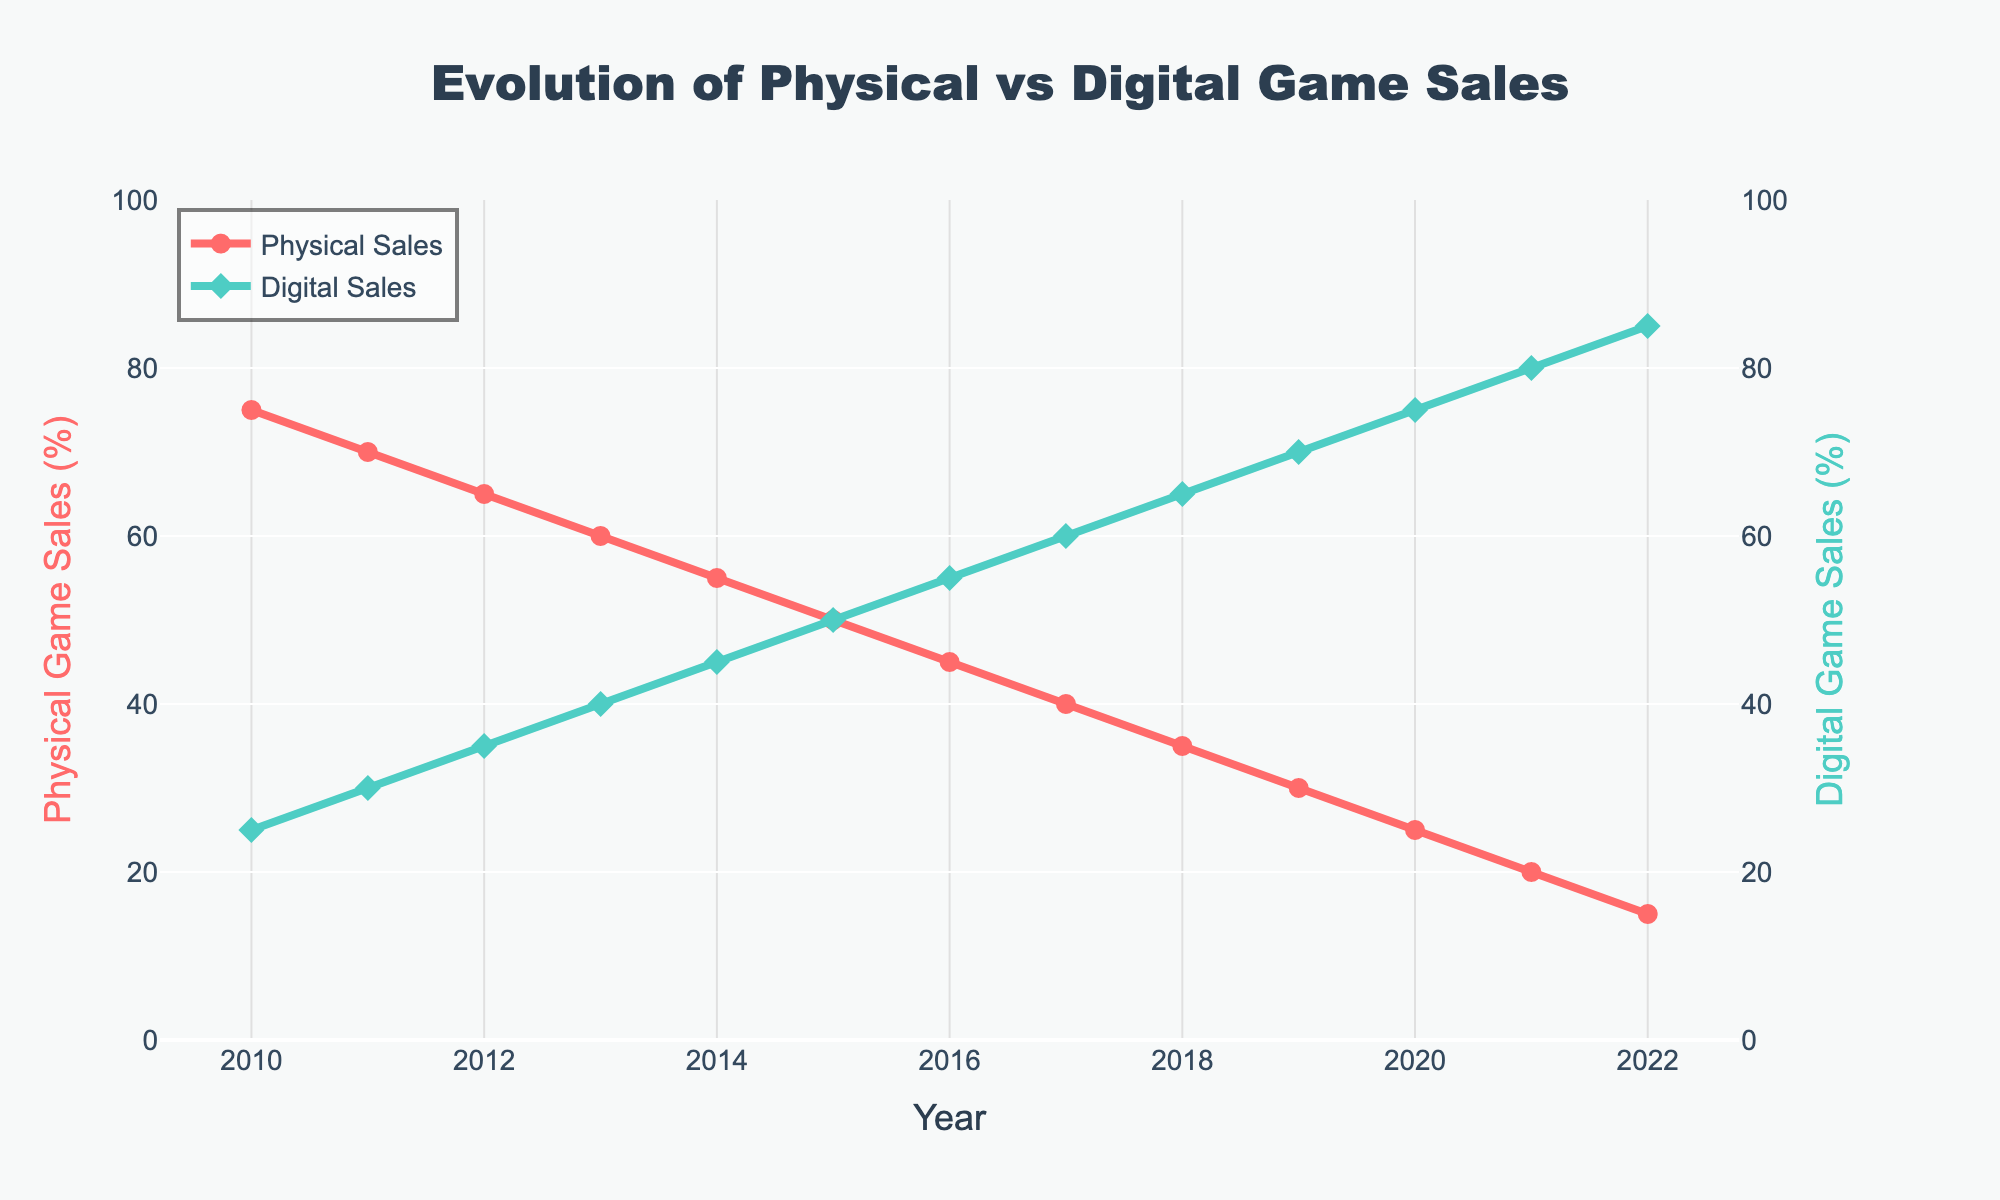What's the ratio of digital game sales to physical game sales in 2020? In 2020, digital game sales are 75% and physical game sales are 25%. So, the ratio is 75/25 = 3.
Answer: 3 How much did the percentage of digital game sales increase from 2010 to 2022? Digital game sales were 25% in 2010 and 85% in 2022. The increase is 85% - 25% = 60%.
Answer: 60% Which year marks the point when digital game sales exceeded physical game sales? The year when digital sales first exceeded physical sales is the year when digital sales percentage is higher than physical sales percentage. This happens in 2015 (50% digital and 50% physical).
Answer: 2015 What's the average percentage of physical game sales from 2010 to 2022? The percentages are: 75, 70, 65, 60, 55, 50, 45, 40, 35, 30, 25, 20, and 15. Sum them up: 75+70+65+60+55+50+45+40+35+30+25+20+15 = 585. There are 13 values, so the average is 585/13 ≈ 45%.
Answer: 45% By how much did physical game sales decrease between 2014 and 2021? Physical game sales were 55% in 2014 and 20% in 2021. The decrease is 55% - 20% = 35%.
Answer: 35% In which year is the difference between physical game sales and digital game sales the smallest? The smallest difference occurs when the absolute value of the difference between physical and digital percentages is smallest. This happens in 2015, where both are 50%.
Answer: 2015 What's the trend in digital game sales percentage from 2010 to 2022? The trend in digital game sales percentage is increasing over time, starting from 25% in 2010 and reaching 85% in 2022.
Answer: Increasing Compare the percentage of physical game sales in 2010 and in 2022. In 2010, physical game sales were 75%, and in 2022 they were 15%. 75% is significantly higher than 15%.
Answer: 75% is higher In which year did physical game sales drop below 40%? Physical game sales dropped below 40% for the first time in 2017, where the percentage is 40%.
Answer: 2017 Which type of game sales had a higher percentage in 2011, and by how much? In 2011, physical game sales were 70%, and digital game sales were 30%. Physical game sales were higher by 70% - 30% = 40%.
Answer: Physical by 40% 